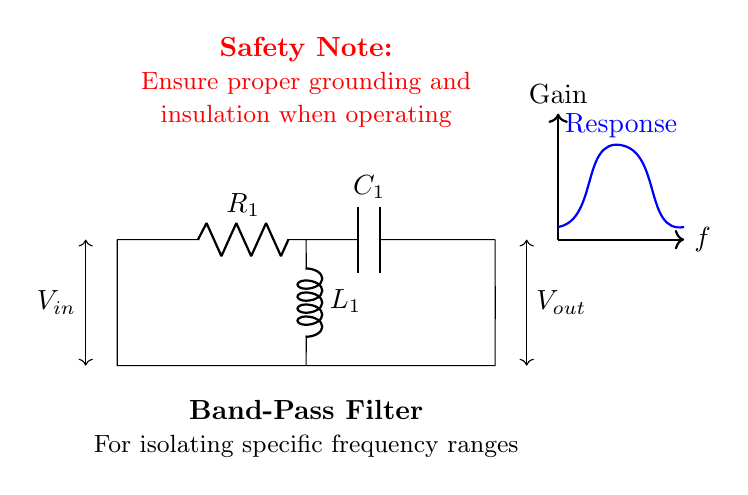What type of filter is represented by the circuit? The circuit is labeled as a Band-Pass Filter, as indicated in the diagram. A band-pass filter allows signals within a certain frequency range to pass while attenuating frequencies outside that range.
Answer: Band-pass filter What components are present in this circuit? The circuit includes a resistor (R1), a capacitor (C1), and an inductor (L1), which are standard components used in filter circuits to manipulate signals.
Answer: Resistor, capacitor, inductor What is the function of the inductor in this circuit? The inductor (L1) in a band-pass filter primarily allows low-frequency signals to pass while blocking high-frequency signals through its property of impedance. This contributes to the filter's ability to isolate a specific frequency range.
Answer: Isolate low frequencies What should be ensured while operating this filter? The circuit has a safety note indicating the need for proper grounding and insulation while operating the device to avoid electrical hazards. This precaution is critical for ensuring safety for machine operators.
Answer: Proper grounding and insulation What happens to signals outside the specified frequency range? Signals that fall outside the specified frequency range are typically attenuated, meaning their amplitude is reduced significantly, allowing only the intended range of frequencies to be transmitted effectively.
Answer: They are attenuated 